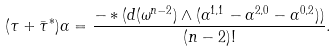<formula> <loc_0><loc_0><loc_500><loc_500>( \tau + \bar { \tau } ^ { * } ) \alpha = \frac { - * ( d ( \omega ^ { n - 2 } ) \wedge ( \alpha ^ { 1 , 1 } - \alpha ^ { 2 , 0 } - \alpha ^ { 0 , 2 } ) ) } { ( n - 2 ) ! } .</formula> 